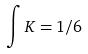Convert formula to latex. <formula><loc_0><loc_0><loc_500><loc_500>\int K = 1 / 6</formula> 